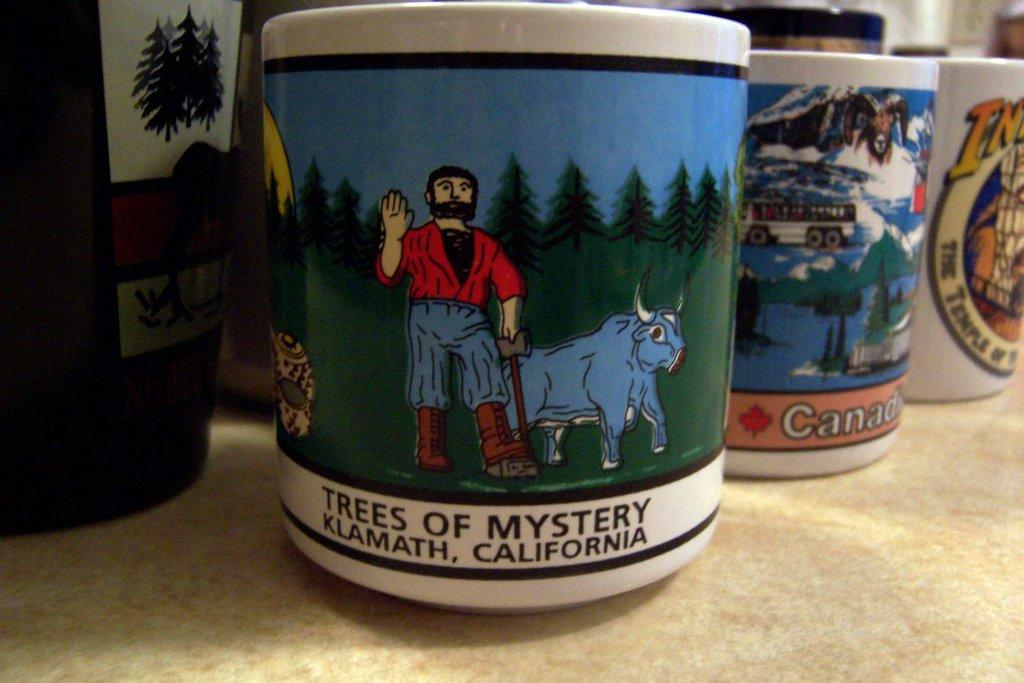What objects are present in the image? There are cups in the image. What is unique about the cups? The cups have images pasted on them. What type of punishment is being handed out in the image? There is no punishment or any indication of punishment in the image; it only features cups with images on them. 